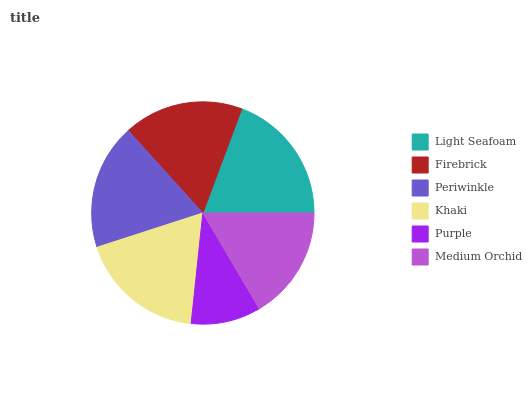Is Purple the minimum?
Answer yes or no. Yes. Is Light Seafoam the maximum?
Answer yes or no. Yes. Is Firebrick the minimum?
Answer yes or no. No. Is Firebrick the maximum?
Answer yes or no. No. Is Light Seafoam greater than Firebrick?
Answer yes or no. Yes. Is Firebrick less than Light Seafoam?
Answer yes or no. Yes. Is Firebrick greater than Light Seafoam?
Answer yes or no. No. Is Light Seafoam less than Firebrick?
Answer yes or no. No. Is Periwinkle the high median?
Answer yes or no. Yes. Is Firebrick the low median?
Answer yes or no. Yes. Is Khaki the high median?
Answer yes or no. No. Is Purple the low median?
Answer yes or no. No. 